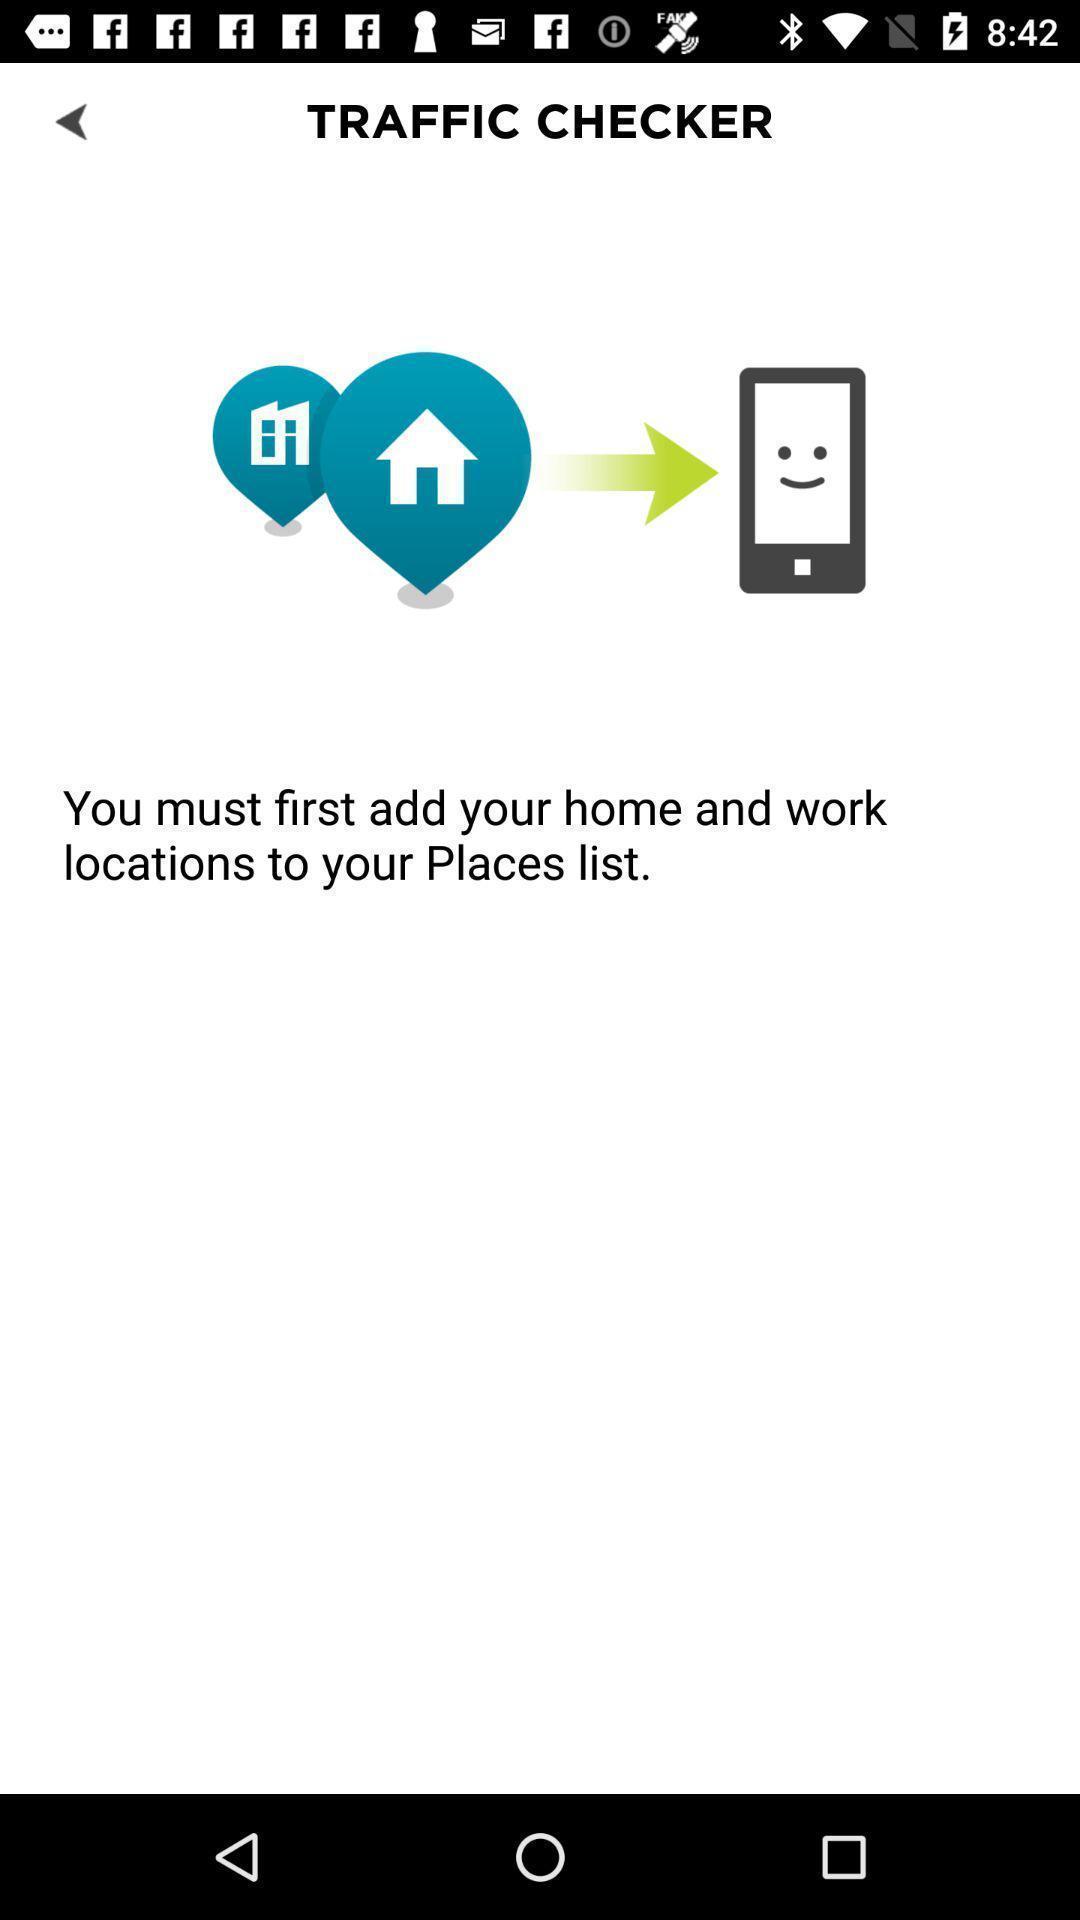Provide a textual representation of this image. Page for adding location of a traffic checking app. 